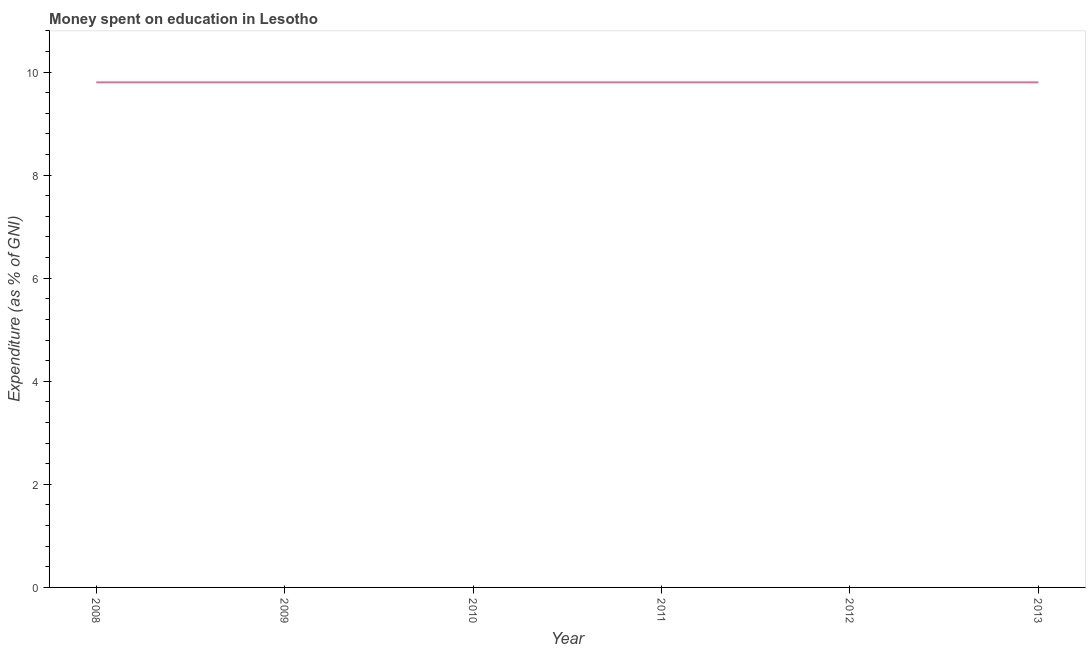What is the sum of the expenditure on education?
Give a very brief answer. 58.8. What is the difference between the expenditure on education in 2008 and 2009?
Your answer should be very brief. 0. What is the average expenditure on education per year?
Offer a very short reply. 9.8. What is the ratio of the expenditure on education in 2008 to that in 2011?
Your answer should be compact. 1. Is the expenditure on education in 2010 less than that in 2013?
Provide a short and direct response. No. What is the difference between the highest and the lowest expenditure on education?
Provide a short and direct response. 0. In how many years, is the expenditure on education greater than the average expenditure on education taken over all years?
Provide a succinct answer. 6. Does the expenditure on education monotonically increase over the years?
Your answer should be compact. No. How many lines are there?
Your response must be concise. 1. How many years are there in the graph?
Keep it short and to the point. 6. Does the graph contain any zero values?
Make the answer very short. No. What is the title of the graph?
Offer a terse response. Money spent on education in Lesotho. What is the label or title of the Y-axis?
Your answer should be very brief. Expenditure (as % of GNI). What is the Expenditure (as % of GNI) in 2008?
Ensure brevity in your answer.  9.8. What is the Expenditure (as % of GNI) of 2012?
Your answer should be very brief. 9.8. What is the difference between the Expenditure (as % of GNI) in 2008 and 2010?
Your answer should be compact. 0. What is the difference between the Expenditure (as % of GNI) in 2008 and 2012?
Keep it short and to the point. 0. What is the difference between the Expenditure (as % of GNI) in 2008 and 2013?
Provide a succinct answer. 0. What is the difference between the Expenditure (as % of GNI) in 2009 and 2011?
Provide a succinct answer. 0. What is the difference between the Expenditure (as % of GNI) in 2010 and 2011?
Make the answer very short. 0. What is the difference between the Expenditure (as % of GNI) in 2010 and 2012?
Keep it short and to the point. 0. What is the difference between the Expenditure (as % of GNI) in 2011 and 2013?
Keep it short and to the point. 0. What is the difference between the Expenditure (as % of GNI) in 2012 and 2013?
Your answer should be very brief. 0. What is the ratio of the Expenditure (as % of GNI) in 2008 to that in 2012?
Ensure brevity in your answer.  1. What is the ratio of the Expenditure (as % of GNI) in 2008 to that in 2013?
Offer a very short reply. 1. What is the ratio of the Expenditure (as % of GNI) in 2009 to that in 2011?
Offer a terse response. 1. What is the ratio of the Expenditure (as % of GNI) in 2009 to that in 2013?
Your response must be concise. 1. What is the ratio of the Expenditure (as % of GNI) in 2010 to that in 2011?
Give a very brief answer. 1. What is the ratio of the Expenditure (as % of GNI) in 2010 to that in 2013?
Keep it short and to the point. 1. What is the ratio of the Expenditure (as % of GNI) in 2012 to that in 2013?
Make the answer very short. 1. 